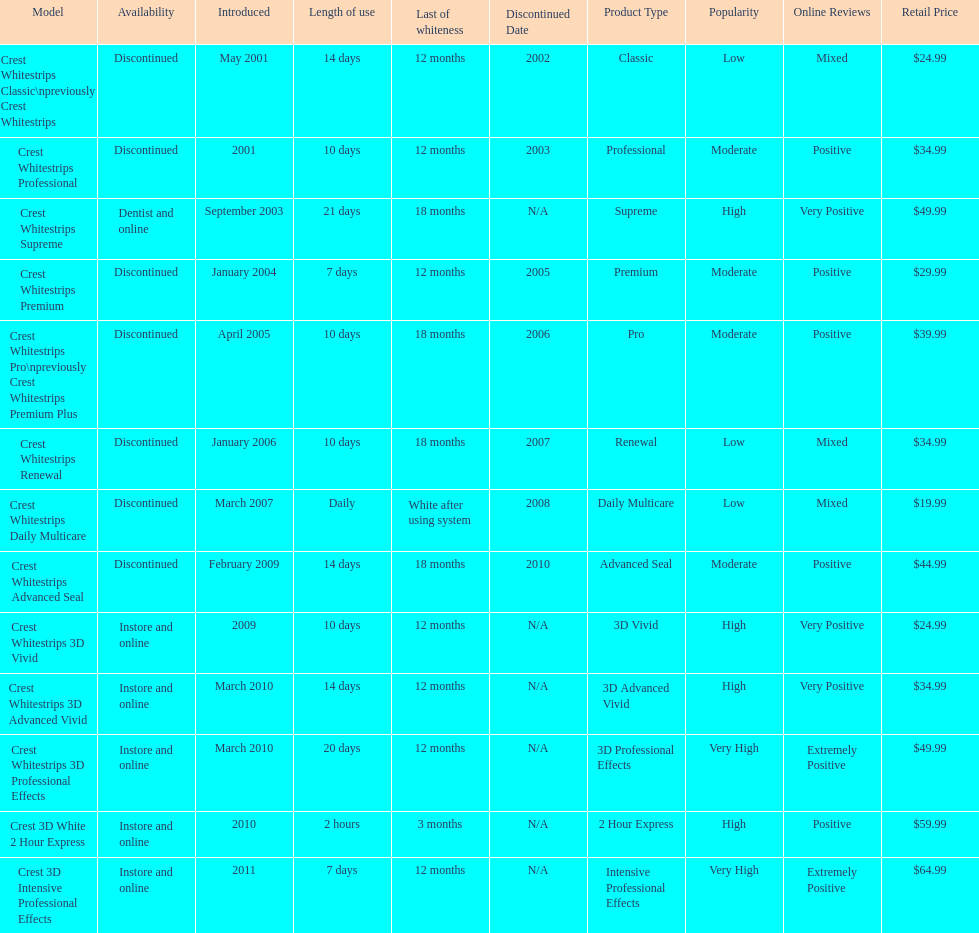How many products have been discontinued? 7. Can you parse all the data within this table? {'header': ['Model', 'Availability', 'Introduced', 'Length of use', 'Last of whiteness', 'Discontinued Date', 'Product Type', 'Popularity', 'Online Reviews', 'Retail Price'], 'rows': [['Crest Whitestrips Classic\\npreviously Crest Whitestrips', 'Discontinued', 'May 2001', '14 days', '12 months', '2002', 'Classic', 'Low', 'Mixed', '$24.99'], ['Crest Whitestrips Professional', 'Discontinued', '2001', '10 days', '12 months', '2003', 'Professional', 'Moderate', 'Positive', '$34.99'], ['Crest Whitestrips Supreme', 'Dentist and online', 'September 2003', '21 days', '18 months', 'N/A', 'Supreme', 'High', 'Very Positive', '$49.99'], ['Crest Whitestrips Premium', 'Discontinued', 'January 2004', '7 days', '12 months', '2005', 'Premium', 'Moderate', 'Positive', '$29.99'], ['Crest Whitestrips Pro\\npreviously Crest Whitestrips Premium Plus', 'Discontinued', 'April 2005', '10 days', '18 months', '2006', 'Pro', 'Moderate', 'Positive', '$39.99'], ['Crest Whitestrips Renewal', 'Discontinued', 'January 2006', '10 days', '18 months', '2007', 'Renewal', 'Low', 'Mixed', '$34.99'], ['Crest Whitestrips Daily Multicare', 'Discontinued', 'March 2007', 'Daily', 'White after using system', '2008', 'Daily Multicare', 'Low', 'Mixed', '$19.99'], ['Crest Whitestrips Advanced Seal', 'Discontinued', 'February 2009', '14 days', '18 months', '2010', 'Advanced Seal', 'Moderate', 'Positive', '$44.99'], ['Crest Whitestrips 3D Vivid', 'Instore and online', '2009', '10 days', '12 months', 'N/A', '3D Vivid', 'High', 'Very Positive', '$24.99'], ['Crest Whitestrips 3D Advanced Vivid', 'Instore and online', 'March 2010', '14 days', '12 months', 'N/A', '3D Advanced Vivid', 'High', 'Very Positive', '$34.99'], ['Crest Whitestrips 3D Professional Effects', 'Instore and online', 'March 2010', '20 days', '12 months', 'N/A', '3D Professional Effects', 'Very High', 'Extremely Positive', '$49.99'], ['Crest 3D White 2 Hour Express', 'Instore and online', '2010', '2 hours', '3 months', 'N/A', '2 Hour Express', 'High', 'Positive', '$59.99'], ['Crest 3D Intensive Professional Effects', 'Instore and online', '2011', '7 days', '12 months', 'N/A', 'Intensive Professional Effects', 'Very High', 'Extremely Positive', '$64.99']]} 